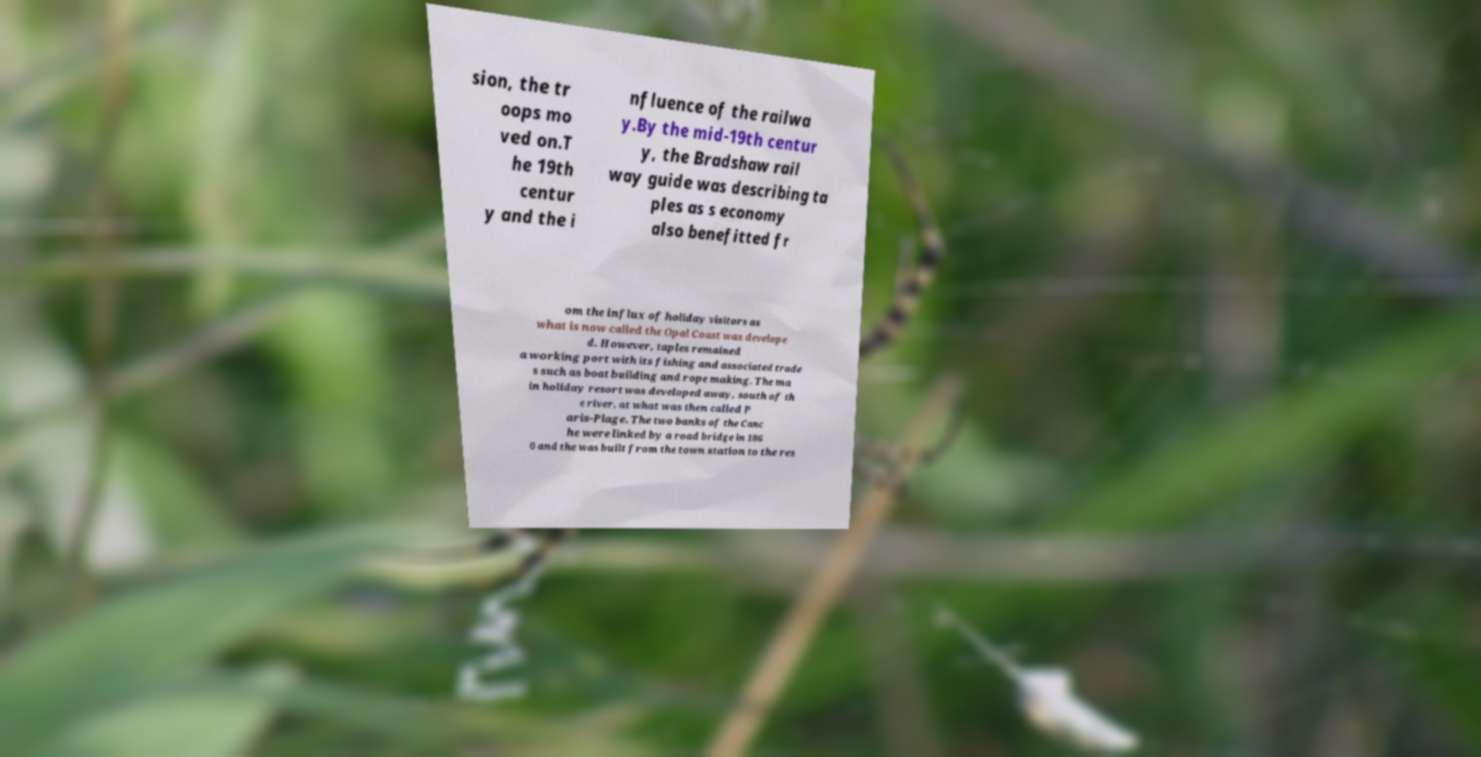What messages or text are displayed in this image? I need them in a readable, typed format. sion, the tr oops mo ved on.T he 19th centur y and the i nfluence of the railwa y.By the mid-19th centur y, the Bradshaw rail way guide was describing ta ples as s economy also benefitted fr om the influx of holiday visitors as what is now called the Opal Coast was develope d. However, taples remained a working port with its fishing and associated trade s such as boat building and rope making. The ma in holiday resort was developed away, south of th e river, at what was then called P aris-Plage. The two banks of the Canc he were linked by a road bridge in 186 0 and the was built from the town station to the res 